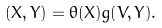<formula> <loc_0><loc_0><loc_500><loc_500>( X , Y ) = \theta ( X ) g ( V , Y ) .</formula> 